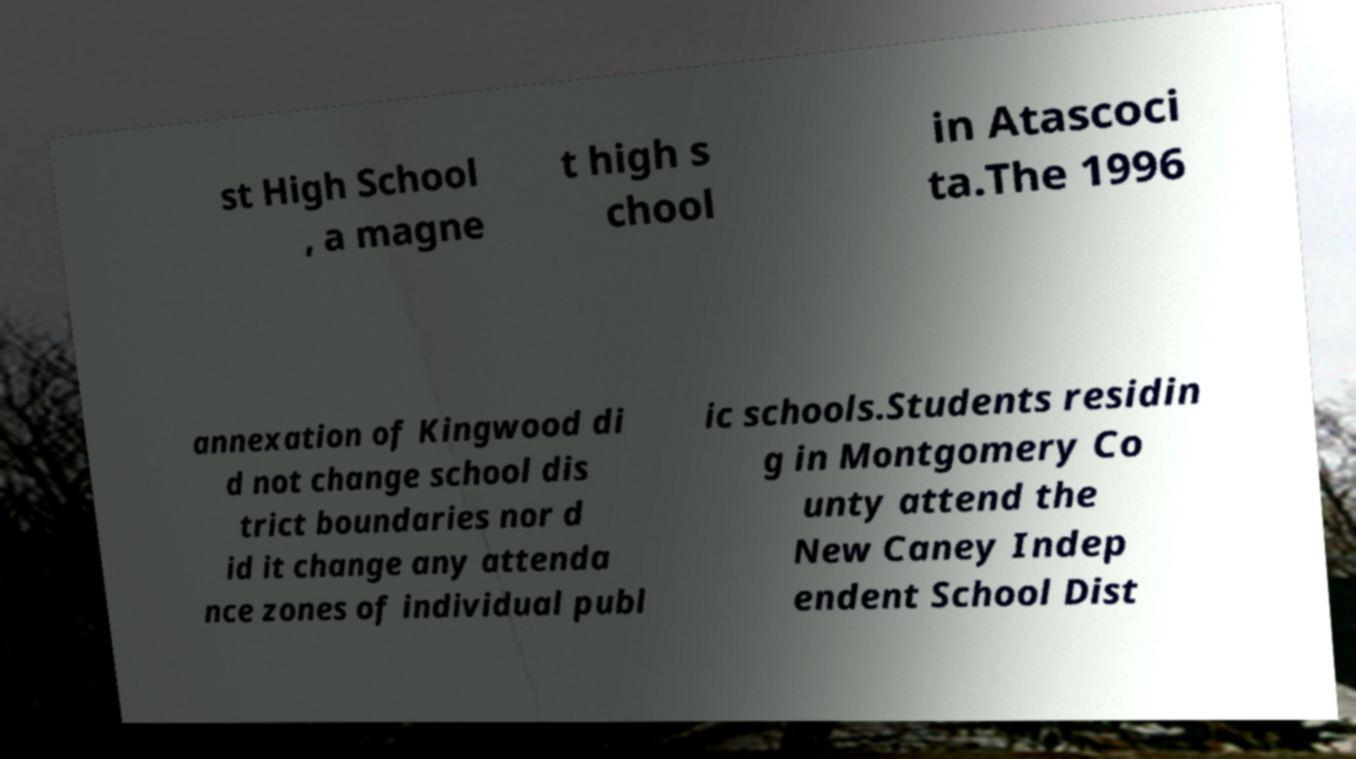For documentation purposes, I need the text within this image transcribed. Could you provide that? st High School , a magne t high s chool in Atascoci ta.The 1996 annexation of Kingwood di d not change school dis trict boundaries nor d id it change any attenda nce zones of individual publ ic schools.Students residin g in Montgomery Co unty attend the New Caney Indep endent School Dist 